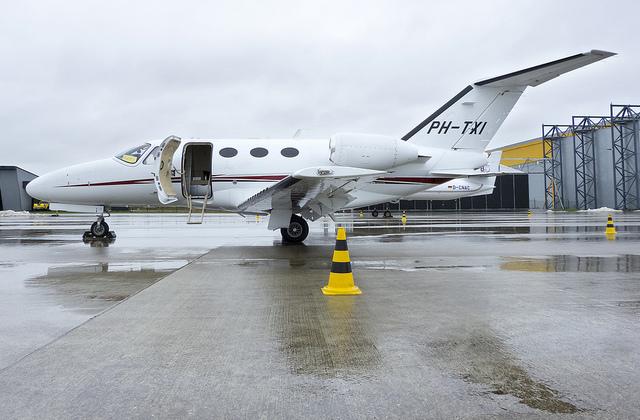Is the plane door open?
Write a very short answer. Yes. Is the plane very large?
Concise answer only. No. What color is this plane?
Write a very short answer. White. What color are the cones in the picture?
Write a very short answer. Yellow and black. 